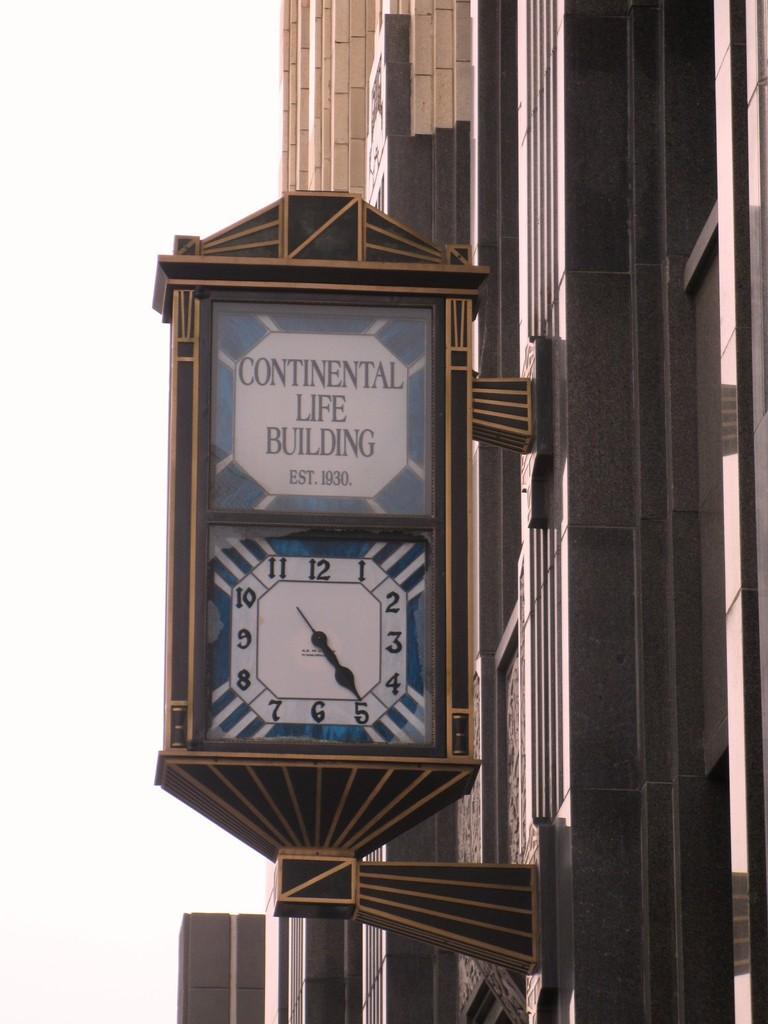What time is displayed on the clock?
Your answer should be compact. 4:25. When was the building established?
Provide a succinct answer. 1930. 